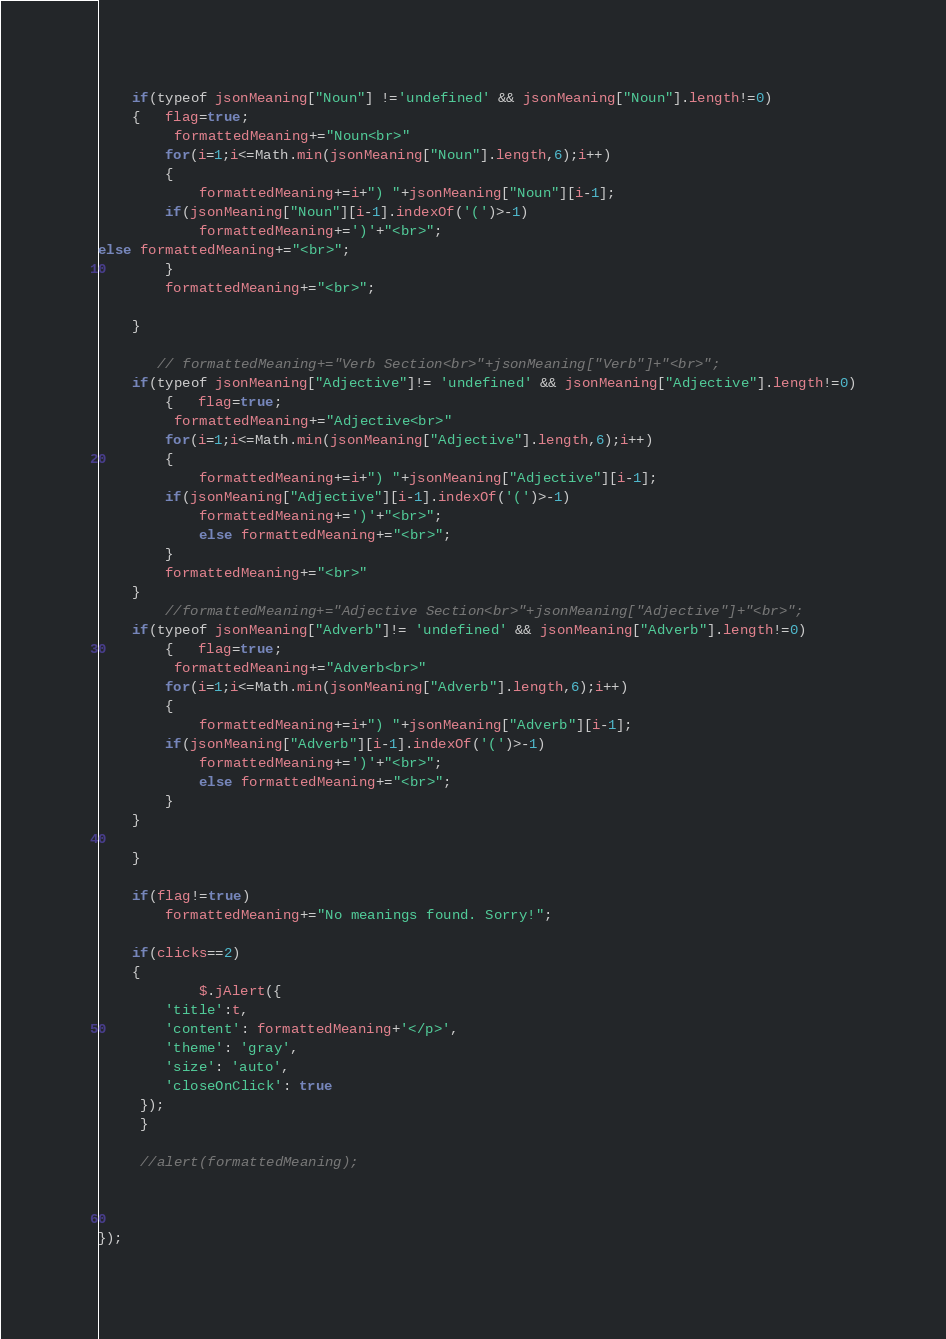Convert code to text. <code><loc_0><loc_0><loc_500><loc_500><_JavaScript_>    if(typeof jsonMeaning["Noun"] !='undefined' && jsonMeaning["Noun"].length!=0)
    {   flag=true;
         formattedMeaning+="Noun<br>"
        for(i=1;i<=Math.min(jsonMeaning["Noun"].length,6);i++)
        {
            formattedMeaning+=i+") "+jsonMeaning["Noun"][i-1];
        if(jsonMeaning["Noun"][i-1].indexOf('(')>-1)
            formattedMeaning+=')'+"<br>";
else formattedMeaning+="<br>";
        }
        formattedMeaning+="<br>";
        
    }
    
       // formattedMeaning+="Verb Section<br>"+jsonMeaning["Verb"]+"<br>";
    if(typeof jsonMeaning["Adjective"]!= 'undefined' && jsonMeaning["Adjective"].length!=0)
        {   flag=true;
         formattedMeaning+="Adjective<br>"
        for(i=1;i<=Math.min(jsonMeaning["Adjective"].length,6);i++)
        {
            formattedMeaning+=i+") "+jsonMeaning["Adjective"][i-1];
        if(jsonMeaning["Adjective"][i-1].indexOf('(')>-1)       
            formattedMeaning+=')'+"<br>";
            else formattedMeaning+="<br>";
        }
        formattedMeaning+="<br>"
    }
        //formattedMeaning+="Adjective Section<br>"+jsonMeaning["Adjective"]+"<br>";
    if(typeof jsonMeaning["Adverb"]!= 'undefined' && jsonMeaning["Adverb"].length!=0)
        {   flag=true;
         formattedMeaning+="Adverb<br>"
        for(i=1;i<=Math.min(jsonMeaning["Adverb"].length,6);i++)
        {
            formattedMeaning+=i+") "+jsonMeaning["Adverb"][i-1];
        if(jsonMeaning["Adverb"][i-1].indexOf('(')>-1)       
            formattedMeaning+=')'+"<br>";
            else formattedMeaning+="<br>";
        }
    }

    }

    if(flag!=true)
        formattedMeaning+="No meanings found. Sorry!";

    if(clicks==2)
    {   
            $.jAlert({
        'title':t,
        'content': formattedMeaning+'</p>',
        'theme': 'gray',
        'size': 'auto',
        'closeOnClick': true
     });
     }

     //alert(formattedMeaning);
     
   
    
});



</code> 